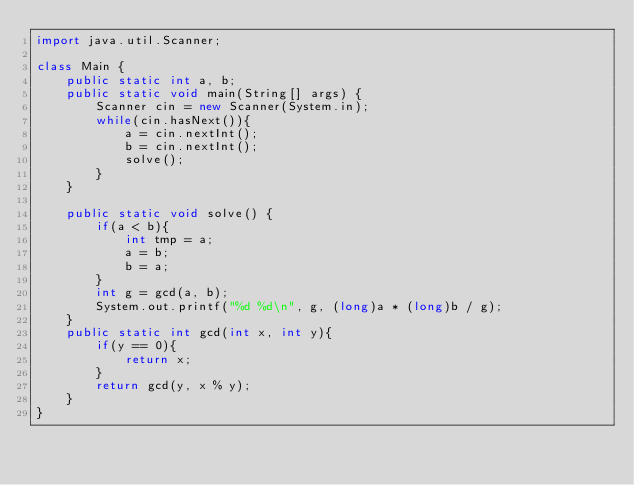<code> <loc_0><loc_0><loc_500><loc_500><_Java_>import java.util.Scanner;

class Main {
	public static int a, b;
	public static void main(String[] args) {
		Scanner cin = new Scanner(System.in);
		while(cin.hasNext()){
			a = cin.nextInt();
			b = cin.nextInt();
			solve();
		}
	}

	public static void solve() {
		if(a < b){
			int tmp = a;
			a = b;
			b = a;
		}
		int g = gcd(a, b);
		System.out.printf("%d %d\n", g, (long)a * (long)b / g);
	}
	public static int gcd(int x, int y){
		if(y == 0){
			return x;
		}
		return gcd(y, x % y);
	}
}</code> 